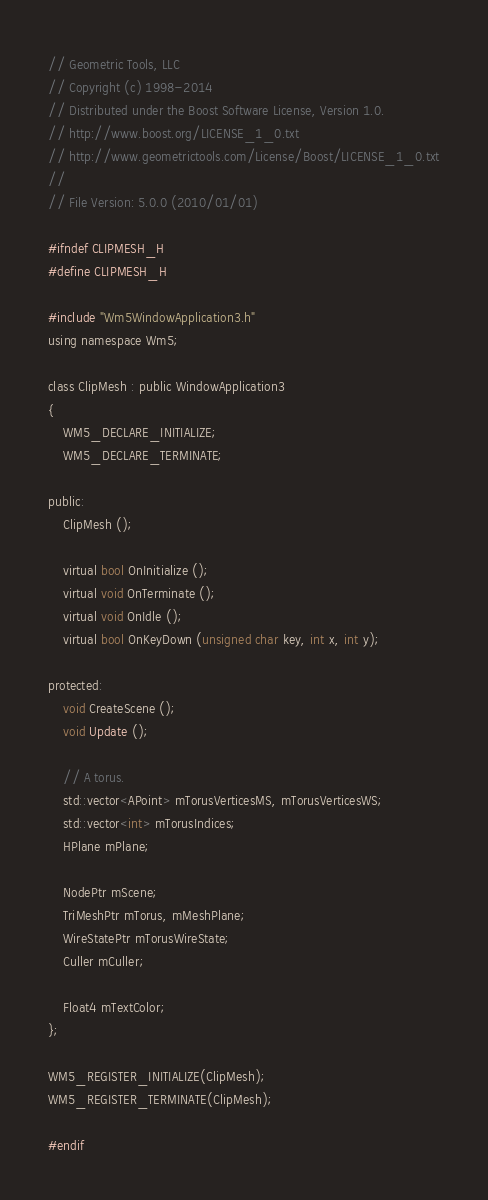Convert code to text. <code><loc_0><loc_0><loc_500><loc_500><_C_>// Geometric Tools, LLC
// Copyright (c) 1998-2014
// Distributed under the Boost Software License, Version 1.0.
// http://www.boost.org/LICENSE_1_0.txt
// http://www.geometrictools.com/License/Boost/LICENSE_1_0.txt
//
// File Version: 5.0.0 (2010/01/01)

#ifndef CLIPMESH_H
#define CLIPMESH_H

#include "Wm5WindowApplication3.h"
using namespace Wm5;

class ClipMesh : public WindowApplication3
{
    WM5_DECLARE_INITIALIZE;
    WM5_DECLARE_TERMINATE;

public:
    ClipMesh ();

    virtual bool OnInitialize ();
    virtual void OnTerminate ();
    virtual void OnIdle ();
    virtual bool OnKeyDown (unsigned char key, int x, int y);

protected:
    void CreateScene ();
    void Update ();

    // A torus.
    std::vector<APoint> mTorusVerticesMS, mTorusVerticesWS;
    std::vector<int> mTorusIndices;
    HPlane mPlane;

    NodePtr mScene;
    TriMeshPtr mTorus, mMeshPlane;
    WireStatePtr mTorusWireState;
    Culler mCuller;

    Float4 mTextColor;
};

WM5_REGISTER_INITIALIZE(ClipMesh);
WM5_REGISTER_TERMINATE(ClipMesh);

#endif
</code> 